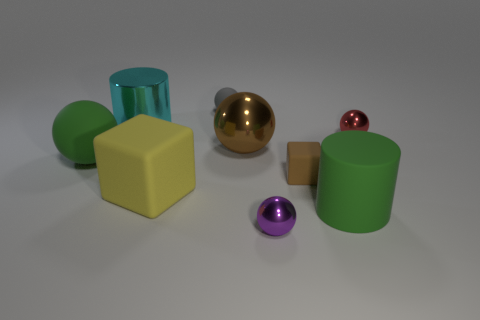Is there a pattern or theme to the arrangement of objects? The arrangement of objects doesn't explicitly follow a recognizable pattern or theme. However, one could interpret the scene as a study in geometry and color contrasts, with varying shapes, like cylinders, spheres, and a cube, as well as distinct colors like green, yellow, gold, purple, and red. This could suggest an artistic or educational purpose, focusing on the visual and tactile qualities of the different forms and surfaces. 